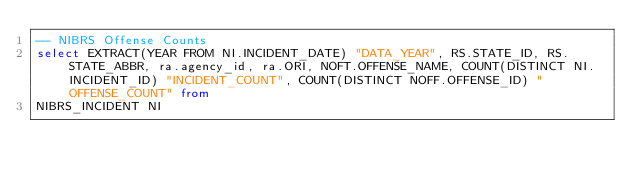<code> <loc_0><loc_0><loc_500><loc_500><_SQL_>-- NIBRS Offense Counts
select EXTRACT(YEAR FROM NI.INCIDENT_DATE) "DATA_YEAR", RS.STATE_ID, RS.STATE_ABBR, ra.agency_id, ra.ORI, NOFT.OFFENSE_NAME, COUNT(DISTINCT NI.INCIDENT_ID) "INCIDENT_COUNT", COUNT(DISTINCT NOFF.OFFENSE_ID) "OFFENSE_COUNT" from
NIBRS_INCIDENT NI</code> 